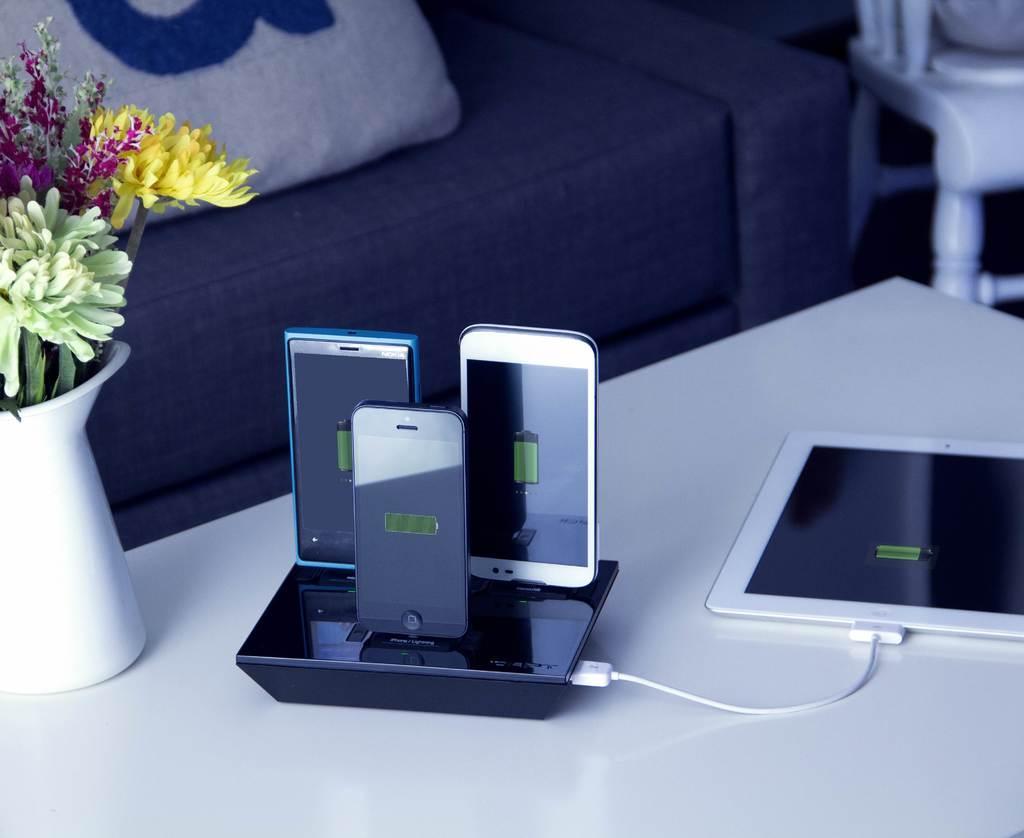Describe this image in one or two sentences. In the center of the image there is a table,on which there is a flower vase. There are three phones. There is a ipad. In the background of the image there is a sofa and a pillow on it. To the right side of the image there is a chair. 